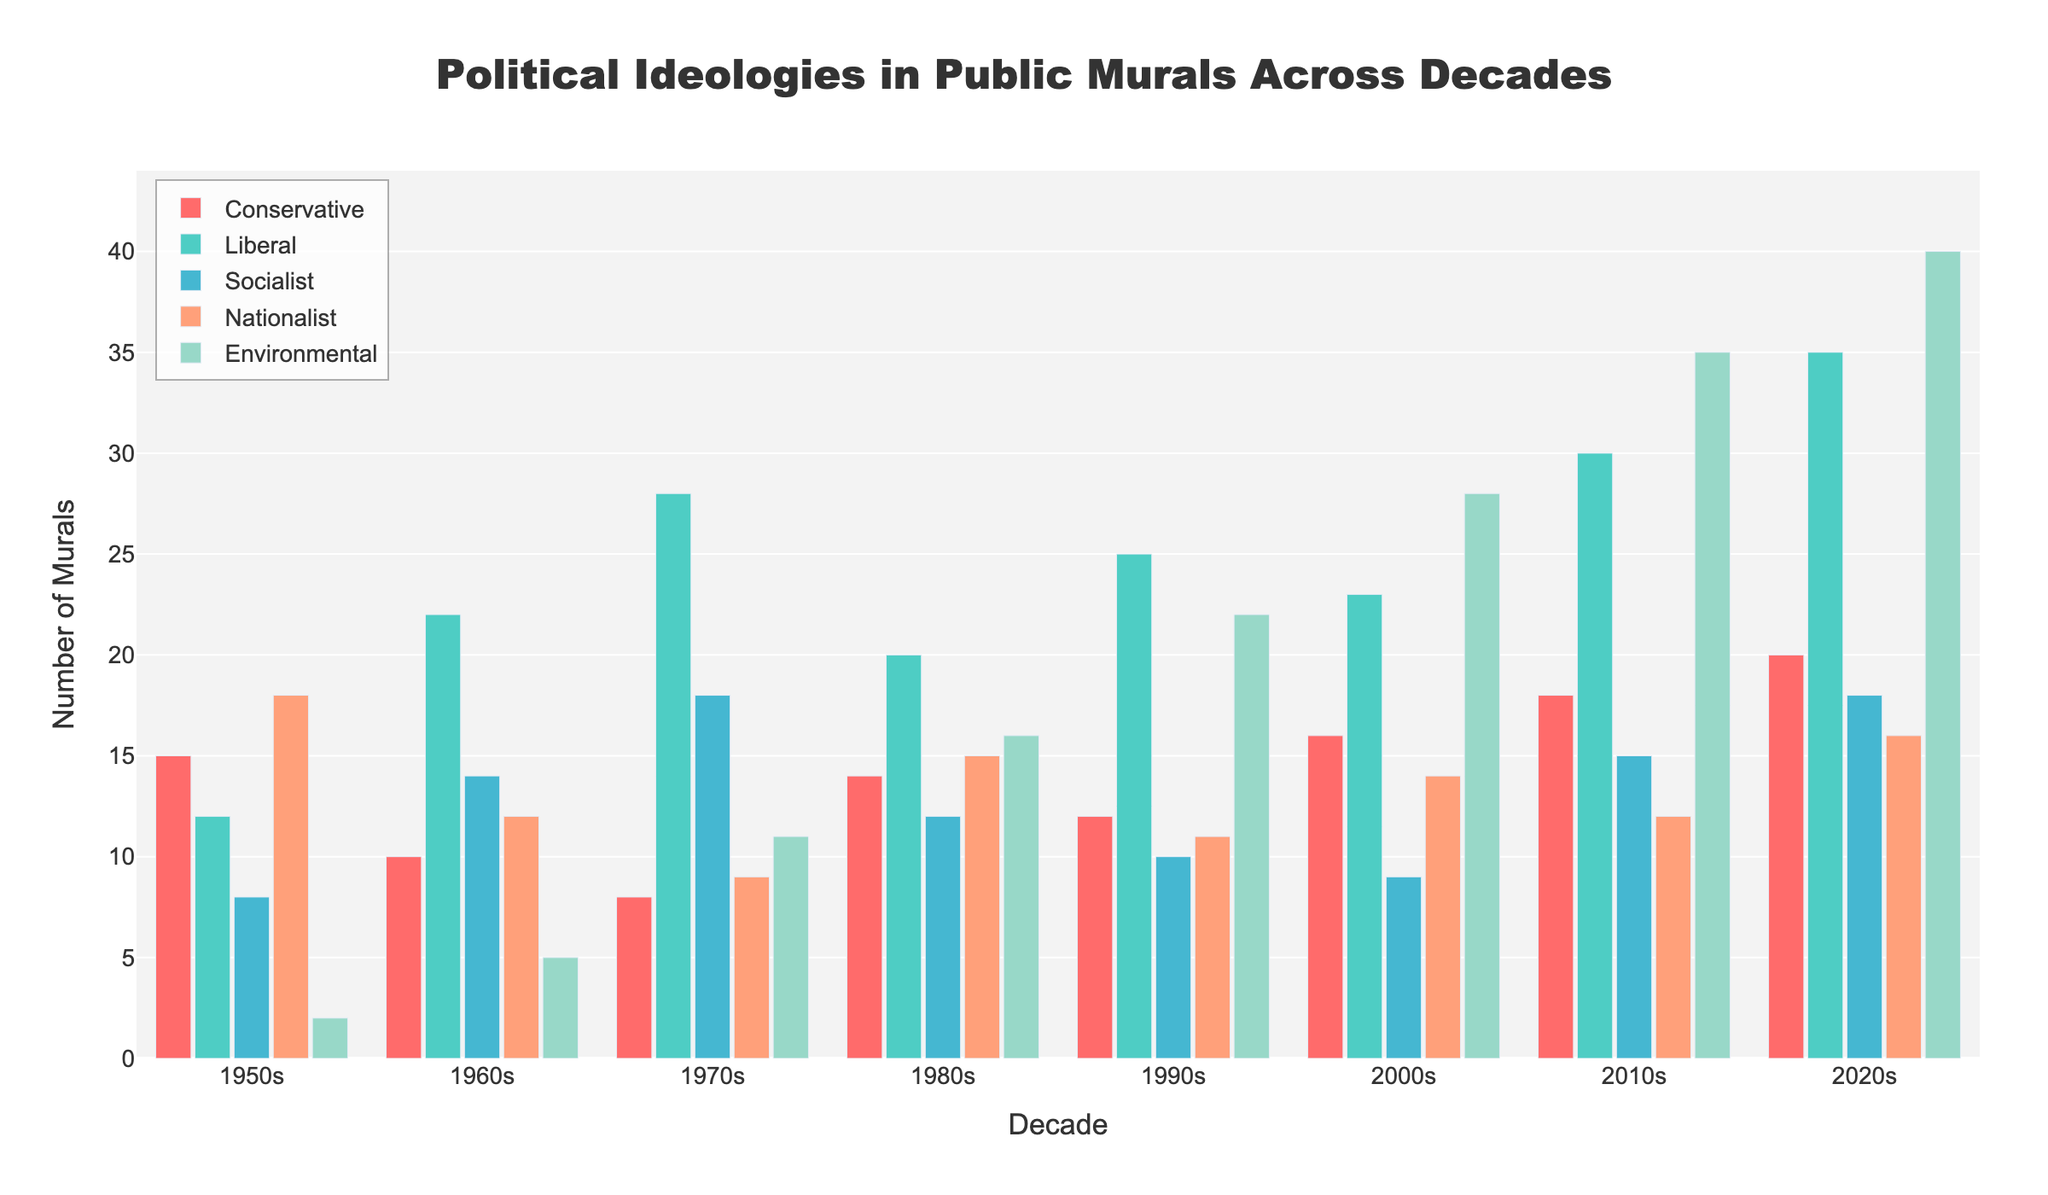What's the total number of murals in the 1970s for Liberal and Socialist ideologies? Sum the number of murals for Liberal and Socialist ideologies in the 1970s: 28 (Liberal) + 18 (Socialist) = 46
Answer: 46 Which decade saw the greatest representation of Environmentalist murals? Compare the number of Environmentalist murals across all decades. The 2020s have the highest number with 40 murals.
Answer: 2020s How did the number of Conservative murals change from the 1950s to the 2020s? Subtract the number of Conservative murals in the 1950s from the number in the 2020s: 20 (2020s) - 15 (1950s) = 5
Answer: Increased by 5 Which ideology had the highest increase in representation from the 1980s to the 2010s? Calculate the increase in the number of murals for each ideology from the 1980s to the 2010s and compare: 
Conservative: 18 - 14 = 4 
Liberal: 30 - 20 = 10 
Socialist: 15 - 12 = 3 
Nationalist: 12 - 15 = -3 
Environmental: 35 - 16 = 19
Answer: Environmentalist What is the average number of Nationalist murals per decade from the 1950s to the 2020s? Add the number of Nationalist murals for each decade and divide by the number of decades (8):
(18 + 12 + 9 + 15 + 11 + 14 + 12 + 16) / 8 = 13.375
Answer: 13.375 In which decade did the Socialist murals outnumber the Conservative murals by the largest margin? Calculate the margin for each decade where Socialist murals outnumber Conservative murals and find the largest one.
1960s: 14 - 10 = 4 
1970s: 18 - 8 = 10 
1980s: 12 - 14 = -2 (not outnumbered) 
1990s: 10 - 12 = -2 (not outnumbered) 
2000s: 9 - 16 = -7 (not outnumbered) 
2010s: 15 - 18 = -3 (not outnumbered) 
2020s: 18 - 20 = -2 (not outnumbered)
Answer: 1970s Which decade saw the most balanced representation across all ideologies? For each decade, examine the distribution of murals across ideologies by checking their range (difference between highest and lowest value). The 1960s show a relatively balanced distribution with:
Conservative: 10, Liberal: 22, Socialist: 14, Nationalist: 12, Environmental: 5 (Range = 22 - 5 = 17)
Answer: 1960s 